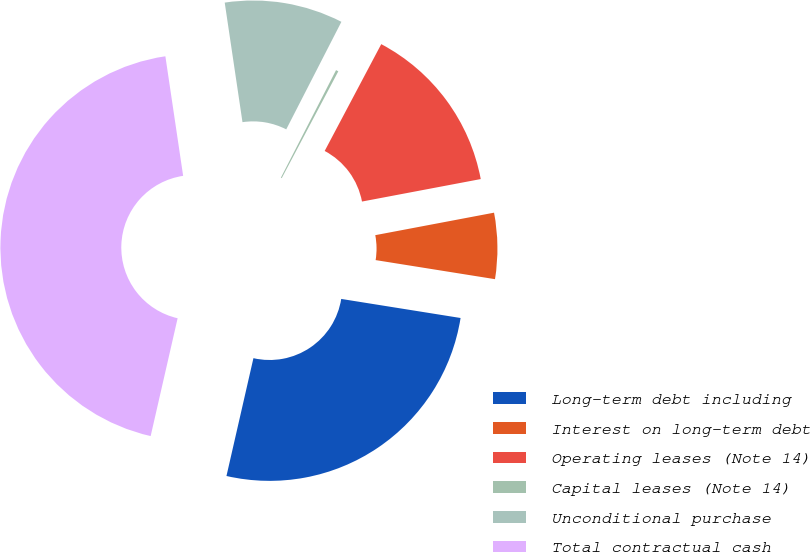<chart> <loc_0><loc_0><loc_500><loc_500><pie_chart><fcel>Long-term debt including<fcel>Interest on long-term debt<fcel>Operating leases (Note 14)<fcel>Capital leases (Note 14)<fcel>Unconditional purchase<fcel>Total contractual cash<nl><fcel>26.06%<fcel>5.5%<fcel>14.27%<fcel>0.21%<fcel>9.89%<fcel>44.07%<nl></chart> 